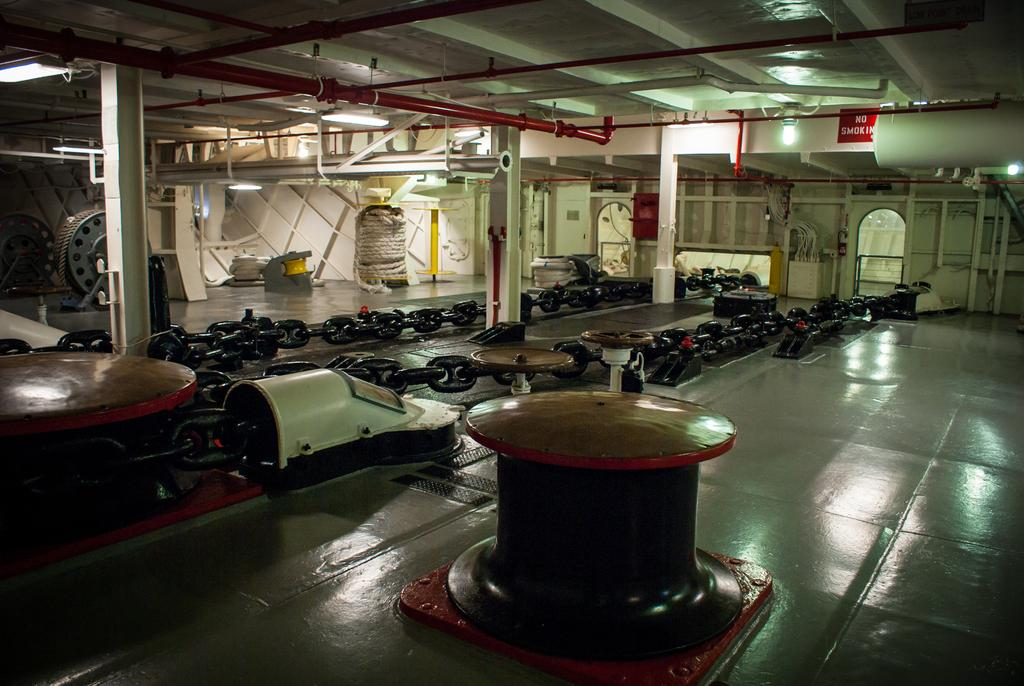What type of structure can be seen in the image? There are chains, a pole, pillars, a wall, a floor, and a roof visible in the image. What is attached to the wheel in the image? There is a rope attached to a wheel in the image. What can be found on the roof in the image? There are pipes and a board on the roof in the image. What type of lighting is present in the image? There are ceiling lights in the image. What type of flowers can be seen in the image? There are no flowers present in the image. What type of medical equipment can be seen in the image? There is no medical equipment present in the image. 